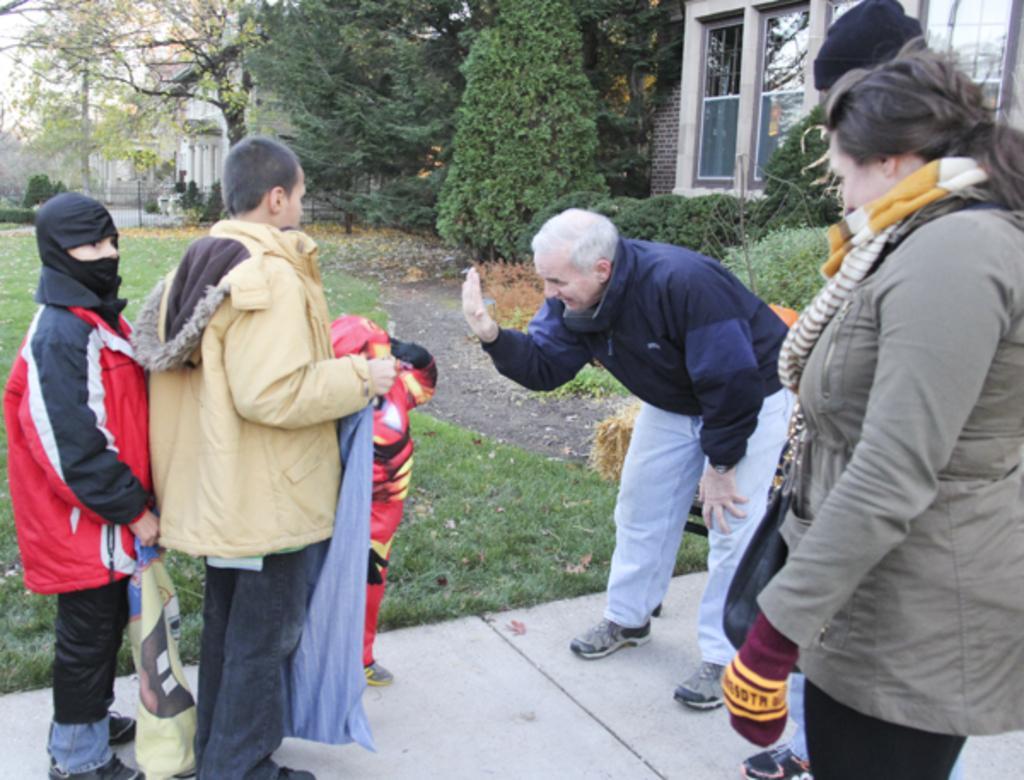How would you summarize this image in a sentence or two? In this image, we can see few people are standing on the walkway. Background we can see grass, trees, plants, houses, walls, pillars, glass windows, grill and sky. 